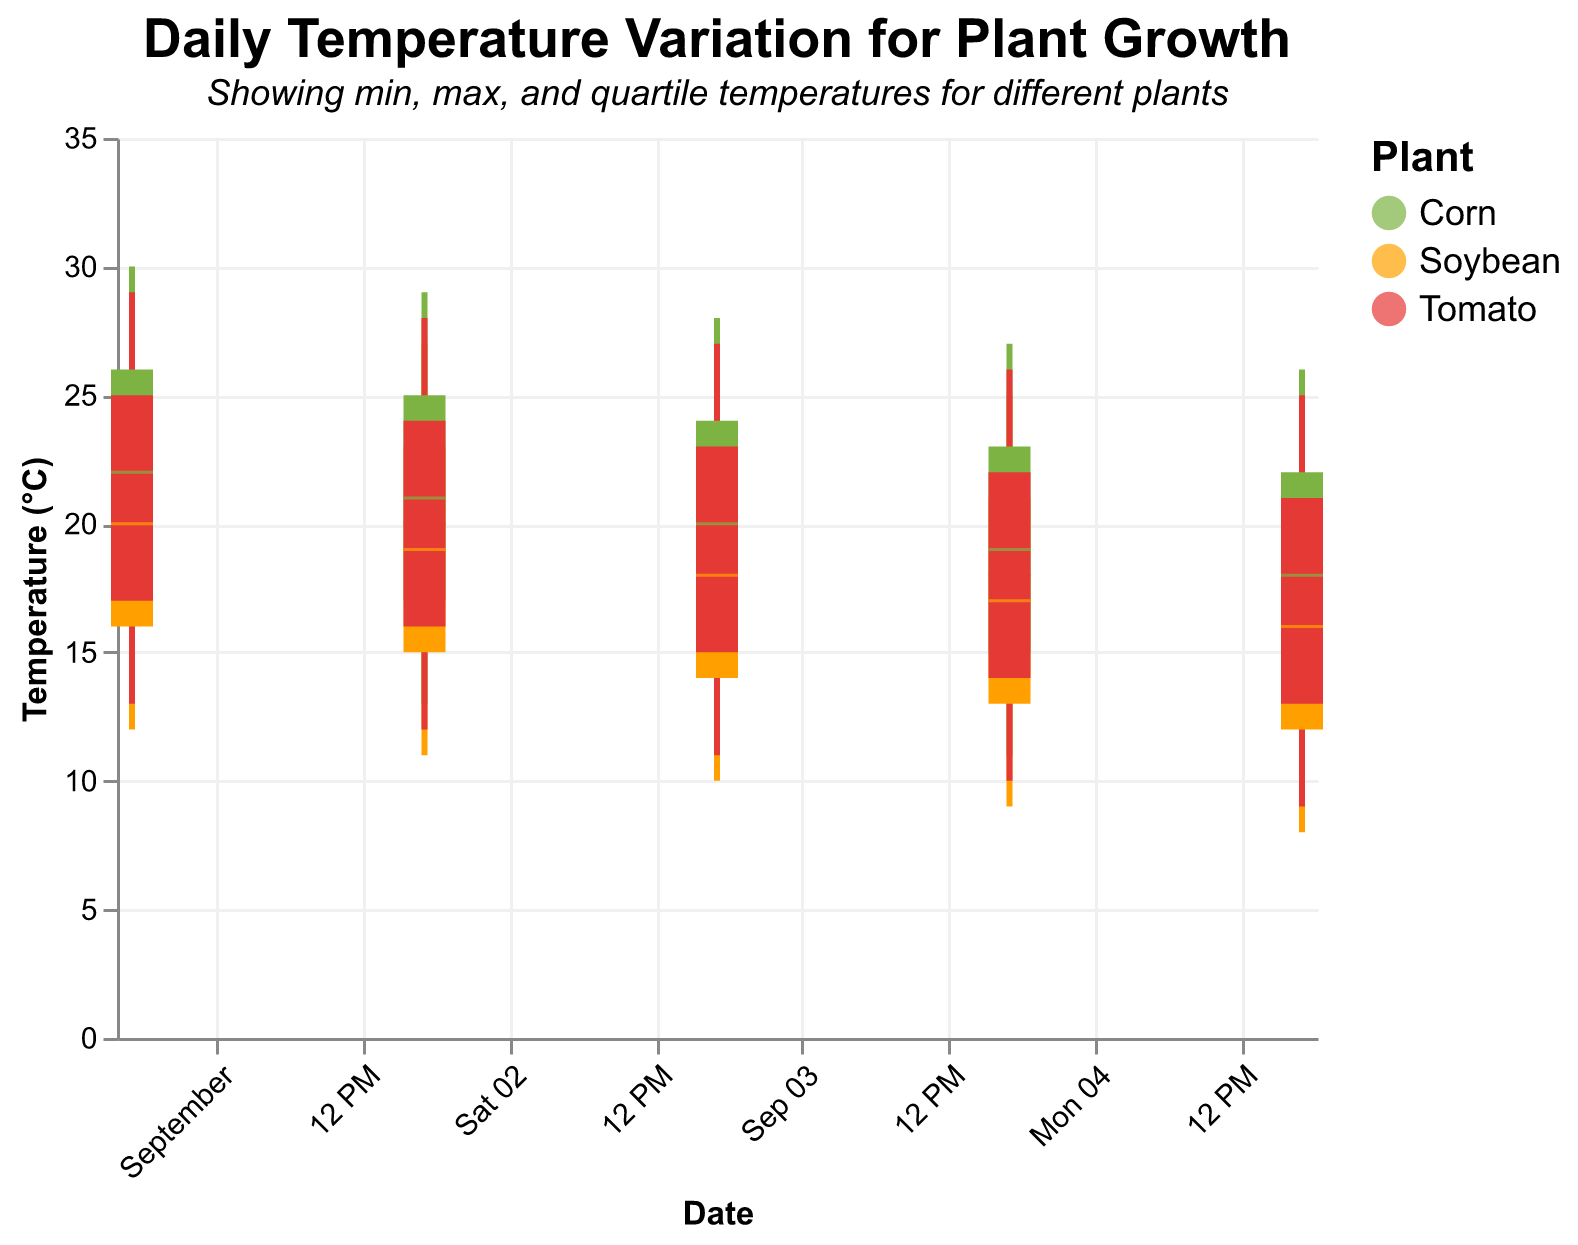What is the title of the figure? The title is usually located at the top of the figure. In this plot, it is clearly stated.
Answer: "Daily Temperature Variation for Plant Growth" What is the highest maximum temperature recorded for Corn over the entire period? We need to find the highest value in the 'MaximumTemperature' column for Corn. The highest is 30°C, recorded on 2023-09-01.
Answer: 30°C On September 3rd, which plant had the lowest minimum temperature? Compare the 'MinimumTemperature' values for all plants on 2023-09-03. Soybean had the lowest minimum temperature of 10°C.
Answer: Soybean Which plant experienced the highest third quartile temperature on September 1st? Check the 'ThirdQuartileTemperature' for all plants on 2023-09-01. Corn had the highest third quartile temperature of 26°C.
Answer: Corn What is the median temperature range for Tomato from September 1 to September 5? Calculate the median of 'MedianTemperature' for Tomato between these dates: (21+20+19+18+17)/5. The median temperature is 19°C.
Answer: 19°C For Soybean, what is the difference between the maximum temperature on September 1st and September 5th? Subtract the 'MaximumTemperature' for Soybean on 2023-09-05 from that on 2023-09-01: 28 - 24 = 4°C.
Answer: 4°C Compare the minimum temperatures of Corn on September 2nd and September 4th. Which day was colder? The 'MinimumTemperature' for Corn on 2023-09-02 was 13°C, and on 2023-09-04 it was 11°C. Therefore, September 4th was colder.
Answer: September 4th Which day had the smallest range of temperatures for Tomato, and what was that range? Calculate the range (Maximum - Minimum) for each day for Tomato. The smallest range was on 2023-09-01 and 2023-09-02 both with (29-13) and (28-12), the range is 16°C.
Answer: 16°C What’s the average first quartile temperature for Corn over the given period? The 'FirstQuartileTemperature' for Corn over the period is (18+17+16+15+14). Average = (18+17+16+15+14)/5 = 16°C.
Answer: 16°C How many plants are displayed in this figure, and what are they? The color legend indicates different plants. There are three plants: Soybean, Corn, and Tomato.
Answer: Three: Soybean, Corn, and Tomato 